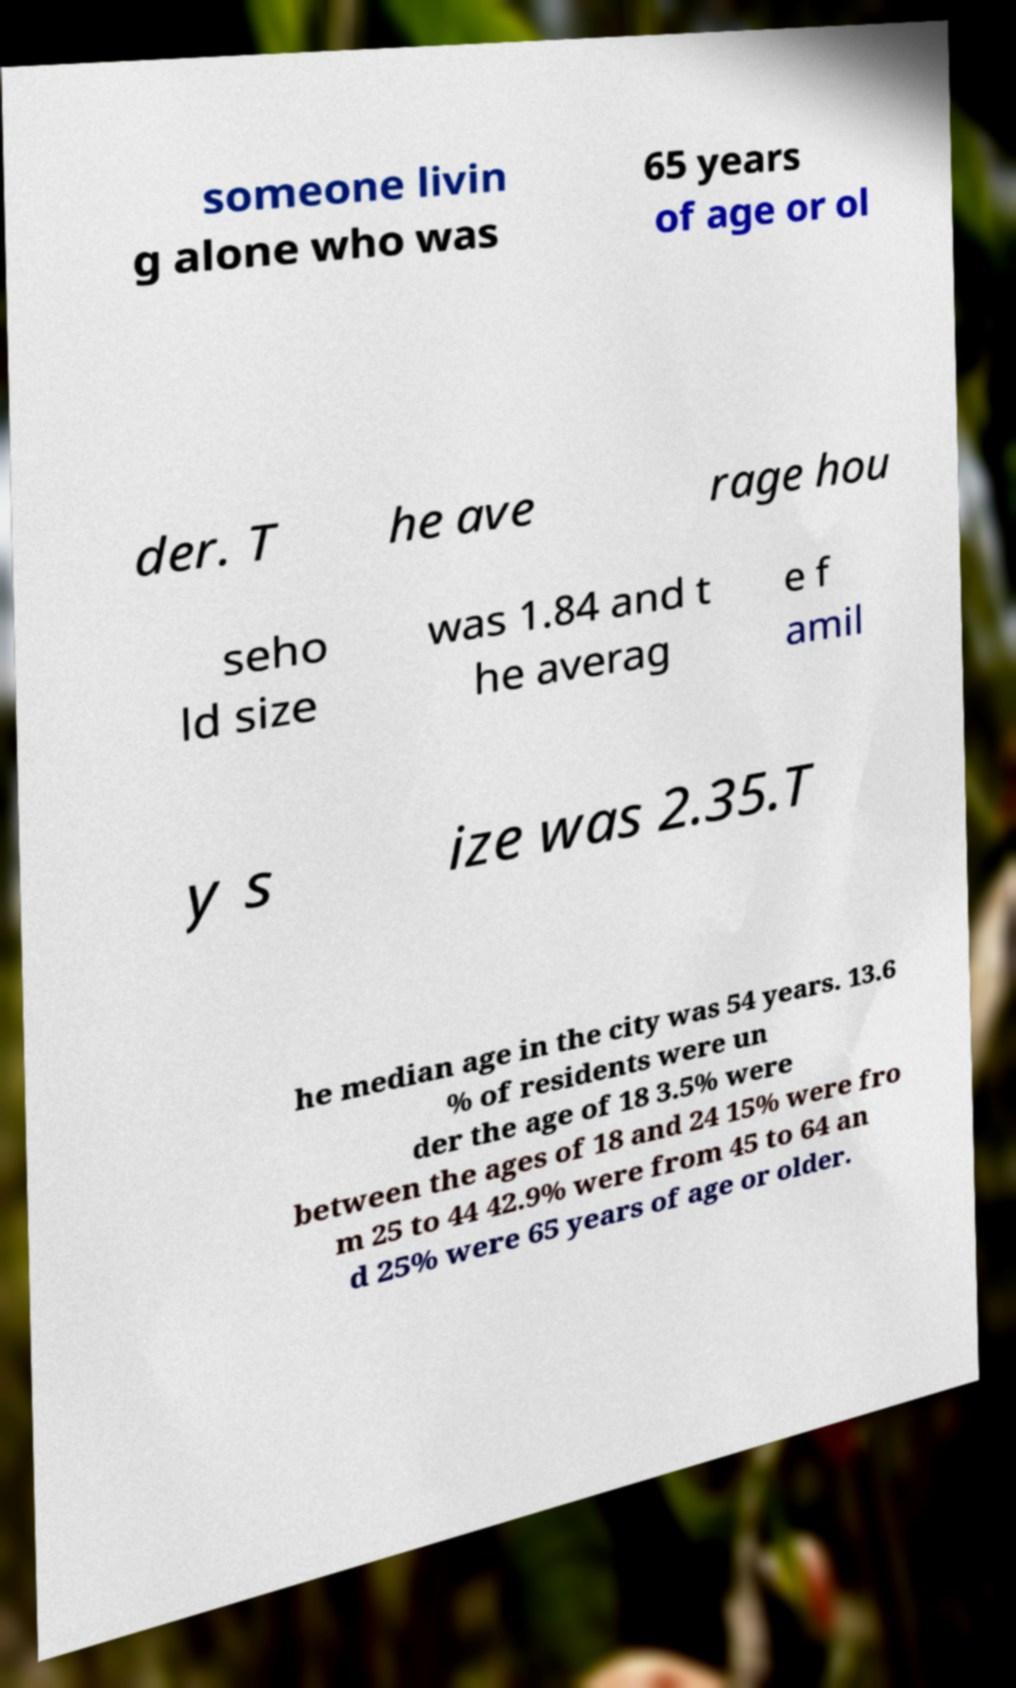For documentation purposes, I need the text within this image transcribed. Could you provide that? someone livin g alone who was 65 years of age or ol der. T he ave rage hou seho ld size was 1.84 and t he averag e f amil y s ize was 2.35.T he median age in the city was 54 years. 13.6 % of residents were un der the age of 18 3.5% were between the ages of 18 and 24 15% were fro m 25 to 44 42.9% were from 45 to 64 an d 25% were 65 years of age or older. 